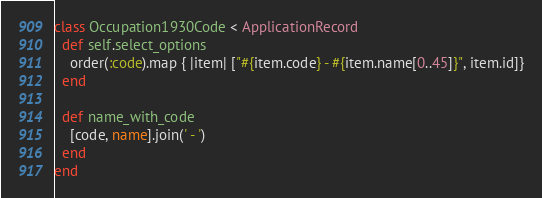<code> <loc_0><loc_0><loc_500><loc_500><_Ruby_>class Occupation1930Code < ApplicationRecord
  def self.select_options
    order(:code).map { |item| ["#{item.code} - #{item.name[0..45]}", item.id]}
  end

  def name_with_code
    [code, name].join(' - ')
  end
end
</code> 